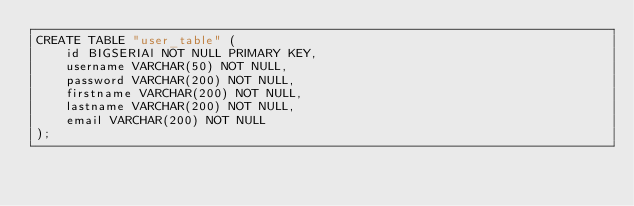<code> <loc_0><loc_0><loc_500><loc_500><_SQL_>CREATE TABLE "user_table" (
    id BIGSERIAl NOT NULL PRIMARY KEY,
    username VARCHAR(50) NOT NULL,
    password VARCHAR(200) NOT NULL,
    firstname VARCHAR(200) NOT NULL,
    lastname VARCHAR(200) NOT NULL,
    email VARCHAR(200) NOT NULL
);</code> 